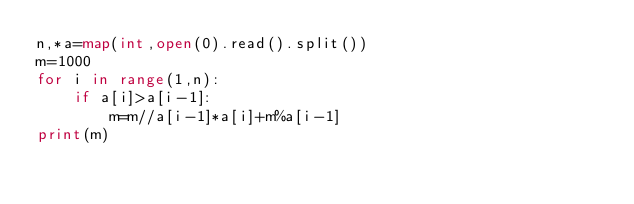<code> <loc_0><loc_0><loc_500><loc_500><_Python_>n,*a=map(int,open(0).read().split())
m=1000
for i in range(1,n):
    if a[i]>a[i-1]:
        m=m//a[i-1]*a[i]+m%a[i-1]
print(m)</code> 